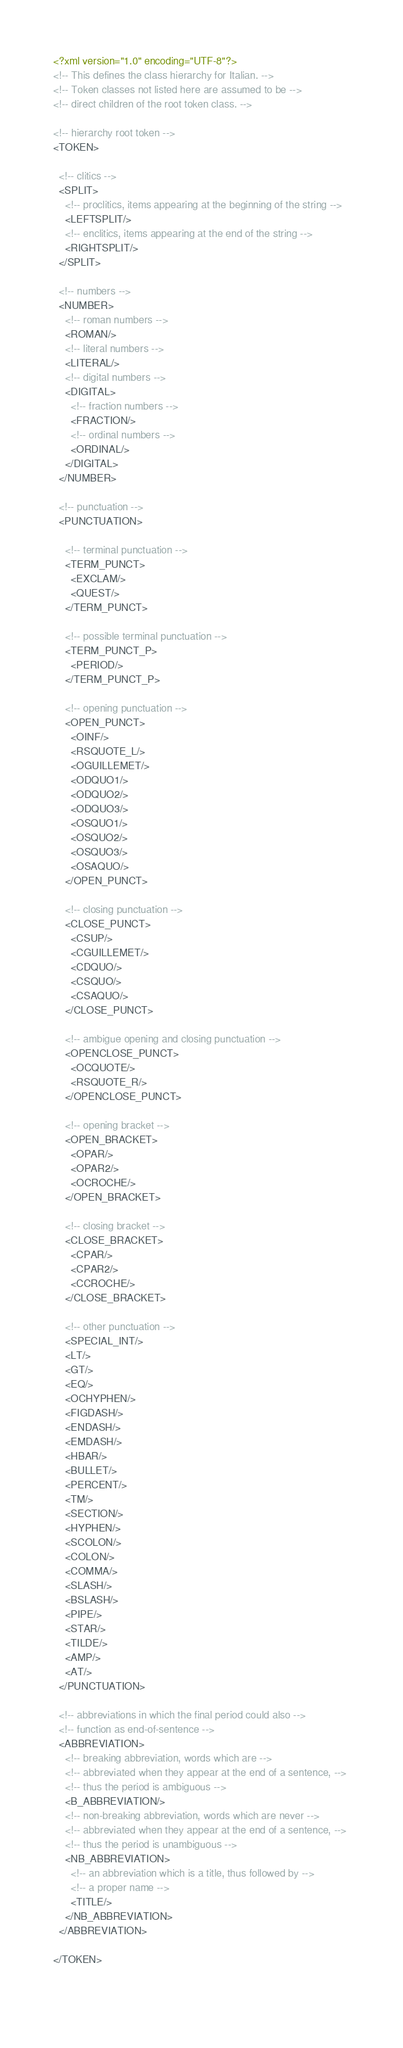Convert code to text. <code><loc_0><loc_0><loc_500><loc_500><_XML_><?xml version="1.0" encoding="UTF-8"?>
<!-- This defines the class hierarchy for Italian. -->
<!-- Token classes not listed here are assumed to be -->
<!-- direct children of the root token class. -->

<!-- hierarchy root token -->
<TOKEN>

  <!-- clitics -->
  <SPLIT>
    <!-- proclitics, items appearing at the beginning of the string -->
    <LEFTSPLIT/>
    <!-- enclitics, items appearing at the end of the string -->
    <RIGHTSPLIT/>
  </SPLIT>  

  <!-- numbers -->
  <NUMBER>
    <!-- roman numbers -->
    <ROMAN/>
    <!-- literal numbers -->
    <LITERAL/>
    <!-- digital numbers -->
    <DIGITAL>
      <!-- fraction numbers -->
      <FRACTION/>
      <!-- ordinal numbers -->
      <ORDINAL/>
    </DIGITAL>  
  </NUMBER>

  <!-- punctuation -->
  <PUNCTUATION>

    <!-- terminal punctuation -->
    <TERM_PUNCT>
      <EXCLAM/>
      <QUEST/>
    </TERM_PUNCT>
    
    <!-- possible terminal punctuation -->
    <TERM_PUNCT_P>
      <PERIOD/>
    </TERM_PUNCT_P>
    
    <!-- opening punctuation -->
    <OPEN_PUNCT>
      <OINF/>
      <RSQUOTE_L/>
      <OGUILLEMET/>
      <ODQUO1/>
      <ODQUO2/>
      <ODQUO3/>
      <OSQUO1/>
      <OSQUO2/>
      <OSQUO3/>
      <OSAQUO/>
    </OPEN_PUNCT>
    
    <!-- closing punctuation -->
    <CLOSE_PUNCT>
      <CSUP/>
      <CGUILLEMET/>
      <CDQUO/>
      <CSQUO/>
      <CSAQUO/>
    </CLOSE_PUNCT>
    
    <!-- ambigue opening and closing punctuation -->
    <OPENCLOSE_PUNCT>
      <OCQUOTE/>
      <RSQUOTE_R/>
    </OPENCLOSE_PUNCT>
    
    <!-- opening bracket -->
    <OPEN_BRACKET>
      <OPAR/>
      <OPAR2/>
      <OCROCHE/>
    </OPEN_BRACKET>
    
    <!-- closing bracket -->
    <CLOSE_BRACKET>
      <CPAR/>
      <CPAR2/>
      <CCROCHE/>
    </CLOSE_BRACKET>
    
    <!-- other punctuation -->
    <SPECIAL_INT/>
    <LT/>
    <GT/>
    <EQ/>
    <OCHYPHEN/>
    <FIGDASH/>
    <ENDASH/>
    <EMDASH/>
    <HBAR/>
    <BULLET/>
    <PERCENT/>
    <TM/>
    <SECTION/>
    <HYPHEN/>
    <SCOLON/>
    <COLON/>
    <COMMA/>
    <SLASH/>
    <BSLASH/>
    <PIPE/>
    <STAR/>
    <TILDE/>
    <AMP/>
    <AT/>
  </PUNCTUATION>

  <!-- abbreviations in which the final period could also -->
  <!-- function as end-of-sentence -->
  <ABBREVIATION>
    <!-- breaking abbreviation, words which are -->
    <!-- abbreviated when they appear at the end of a sentence, --> 
    <!-- thus the period is ambiguous -->
    <B_ABBREVIATION/>
    <!-- non-breaking abbreviation, words which are never -->
    <!-- abbreviated when they appear at the end of a sentence, --> 
    <!-- thus the period is unambiguous -->
    <NB_ABBREVIATION>
      <!-- an abbreviation which is a title, thus followed by -->
      <!-- a proper name -->
      <TITLE/>
    </NB_ABBREVIATION>
  </ABBREVIATION>

</TOKEN>
  
    
</code> 